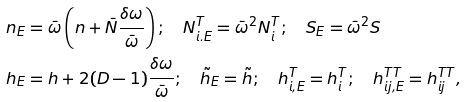<formula> <loc_0><loc_0><loc_500><loc_500>& n _ { E } = \bar { \omega } \left ( n + \bar { N } \frac { \delta \omega } { \bar { \omega } } \right ) ; \quad N _ { i . E } ^ { T } = \bar { \omega } ^ { 2 } N _ { i } ^ { T } ; \quad S _ { E } = \bar { \omega } ^ { 2 } S \\ & h _ { E } = h + 2 ( D - 1 ) \frac { \delta \omega } { \bar { \omega } } ; \quad \tilde { h } _ { E } = \tilde { h } ; \quad h _ { i , E } ^ { T } = h _ { i } ^ { T } ; \quad h _ { i j , E } ^ { T T } = h _ { i j } ^ { T T } ,</formula> 